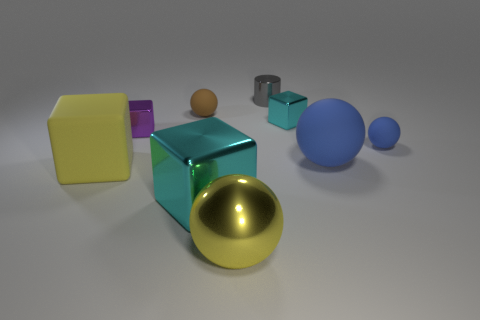Subtract all tiny cyan shiny cubes. How many cubes are left? 3 Subtract all yellow spheres. How many spheres are left? 3 Add 1 large cyan metallic cubes. How many objects exist? 10 Subtract 1 cylinders. How many cylinders are left? 0 Subtract all yellow cylinders. Subtract all gray balls. How many cylinders are left? 1 Subtract all brown cylinders. How many brown spheres are left? 1 Subtract all metal blocks. Subtract all big blue rubber spheres. How many objects are left? 5 Add 7 purple metallic objects. How many purple metallic objects are left? 8 Add 4 big blue things. How many big blue things exist? 5 Subtract 0 red cubes. How many objects are left? 9 